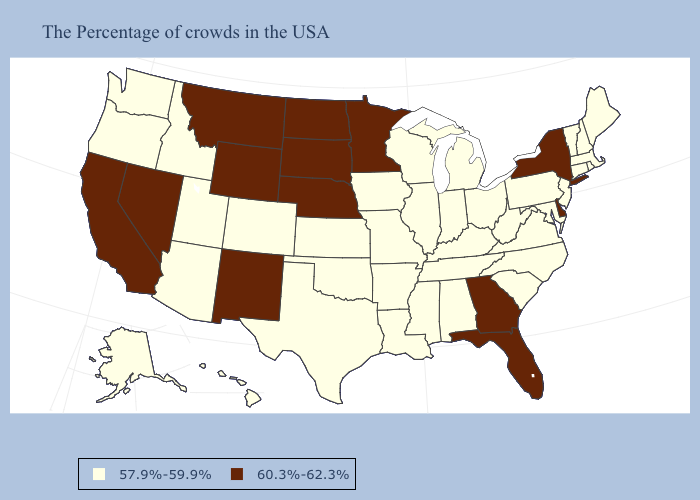Does Montana have the highest value in the USA?
Write a very short answer. Yes. How many symbols are there in the legend?
Write a very short answer. 2. Name the states that have a value in the range 60.3%-62.3%?
Write a very short answer. New York, Delaware, Florida, Georgia, Minnesota, Nebraska, South Dakota, North Dakota, Wyoming, New Mexico, Montana, Nevada, California. Name the states that have a value in the range 60.3%-62.3%?
Quick response, please. New York, Delaware, Florida, Georgia, Minnesota, Nebraska, South Dakota, North Dakota, Wyoming, New Mexico, Montana, Nevada, California. Does Illinois have the same value as Vermont?
Answer briefly. Yes. What is the value of Louisiana?
Short answer required. 57.9%-59.9%. Does New Hampshire have the same value as California?
Quick response, please. No. Among the states that border Indiana , which have the lowest value?
Answer briefly. Ohio, Michigan, Kentucky, Illinois. Name the states that have a value in the range 60.3%-62.3%?
Write a very short answer. New York, Delaware, Florida, Georgia, Minnesota, Nebraska, South Dakota, North Dakota, Wyoming, New Mexico, Montana, Nevada, California. What is the lowest value in states that border Vermont?
Give a very brief answer. 57.9%-59.9%. Name the states that have a value in the range 57.9%-59.9%?
Quick response, please. Maine, Massachusetts, Rhode Island, New Hampshire, Vermont, Connecticut, New Jersey, Maryland, Pennsylvania, Virginia, North Carolina, South Carolina, West Virginia, Ohio, Michigan, Kentucky, Indiana, Alabama, Tennessee, Wisconsin, Illinois, Mississippi, Louisiana, Missouri, Arkansas, Iowa, Kansas, Oklahoma, Texas, Colorado, Utah, Arizona, Idaho, Washington, Oregon, Alaska, Hawaii. How many symbols are there in the legend?
Keep it brief. 2. Name the states that have a value in the range 60.3%-62.3%?
Be succinct. New York, Delaware, Florida, Georgia, Minnesota, Nebraska, South Dakota, North Dakota, Wyoming, New Mexico, Montana, Nevada, California. What is the lowest value in the USA?
Concise answer only. 57.9%-59.9%. What is the value of Oklahoma?
Short answer required. 57.9%-59.9%. 